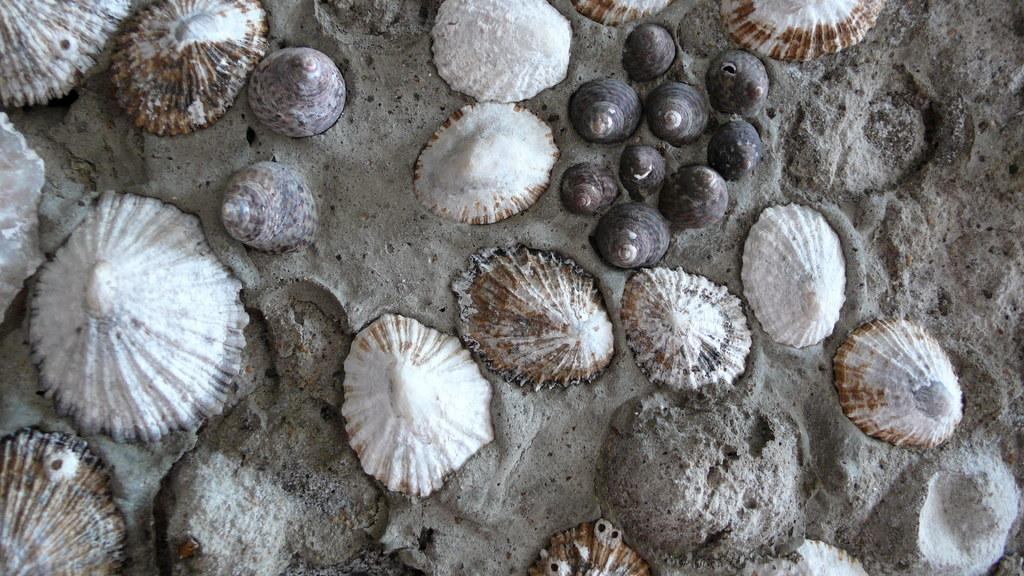What type of surface is visible in the image? There is sand in the image. What else can be found on the sand in the image? There are different kinds of shells in the image. Can you describe the colors of the shells? The shells have different colors, including white, black, and brown. What type of sofa can be seen in the image? There is no sofa present in the image; it features sand and shells. How does the image reflect the mind of the person who created it? The image does not reflect the mind of the person who created it, as it only shows sand and shells. 